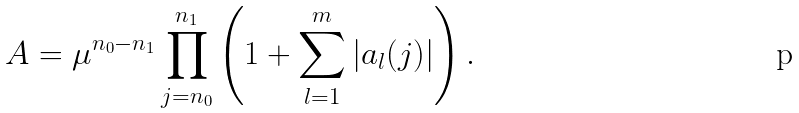<formula> <loc_0><loc_0><loc_500><loc_500>A = \mu ^ { n _ { 0 } - n _ { 1 } } \prod _ { j = n _ { 0 } } ^ { n _ { 1 } } \left ( 1 + \sum _ { l = 1 } ^ { m } | a _ { l } ( j ) | \right ) .</formula> 